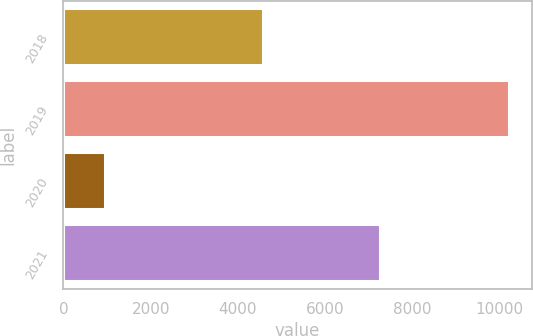Convert chart to OTSL. <chart><loc_0><loc_0><loc_500><loc_500><bar_chart><fcel>2018<fcel>2019<fcel>2020<fcel>2021<nl><fcel>4563<fcel>10220<fcel>959<fcel>7249<nl></chart> 